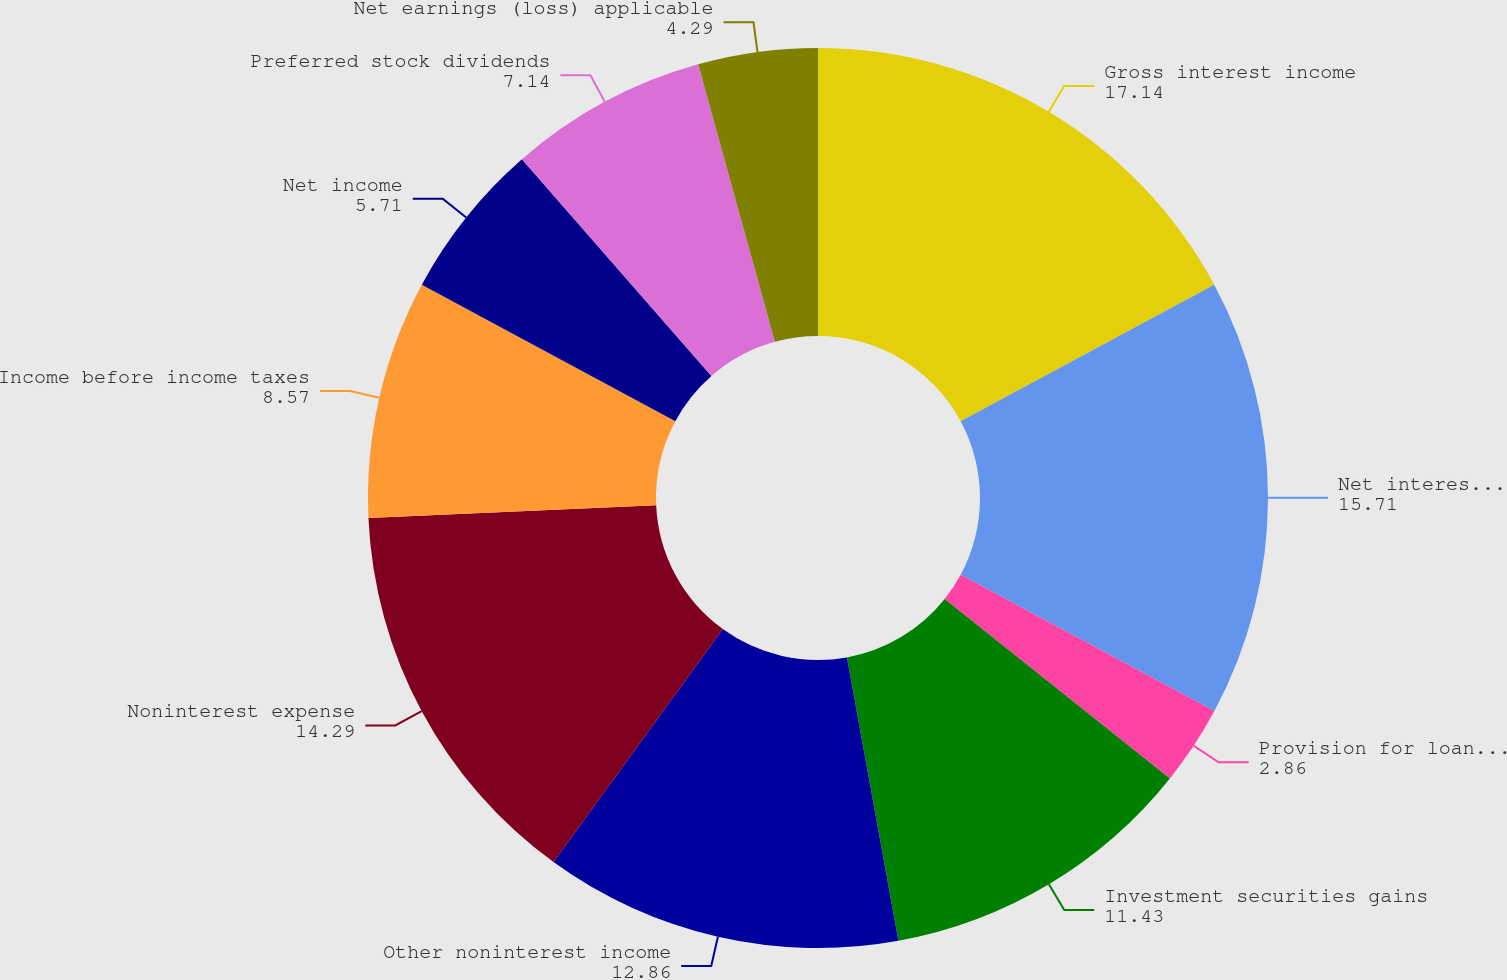Convert chart. <chart><loc_0><loc_0><loc_500><loc_500><pie_chart><fcel>Gross interest income<fcel>Net interest income<fcel>Provision for loan losses<fcel>Investment securities gains<fcel>Other noninterest income<fcel>Noninterest expense<fcel>Income before income taxes<fcel>Net income<fcel>Preferred stock dividends<fcel>Net earnings (loss) applicable<nl><fcel>17.14%<fcel>15.71%<fcel>2.86%<fcel>11.43%<fcel>12.86%<fcel>14.29%<fcel>8.57%<fcel>5.71%<fcel>7.14%<fcel>4.29%<nl></chart> 